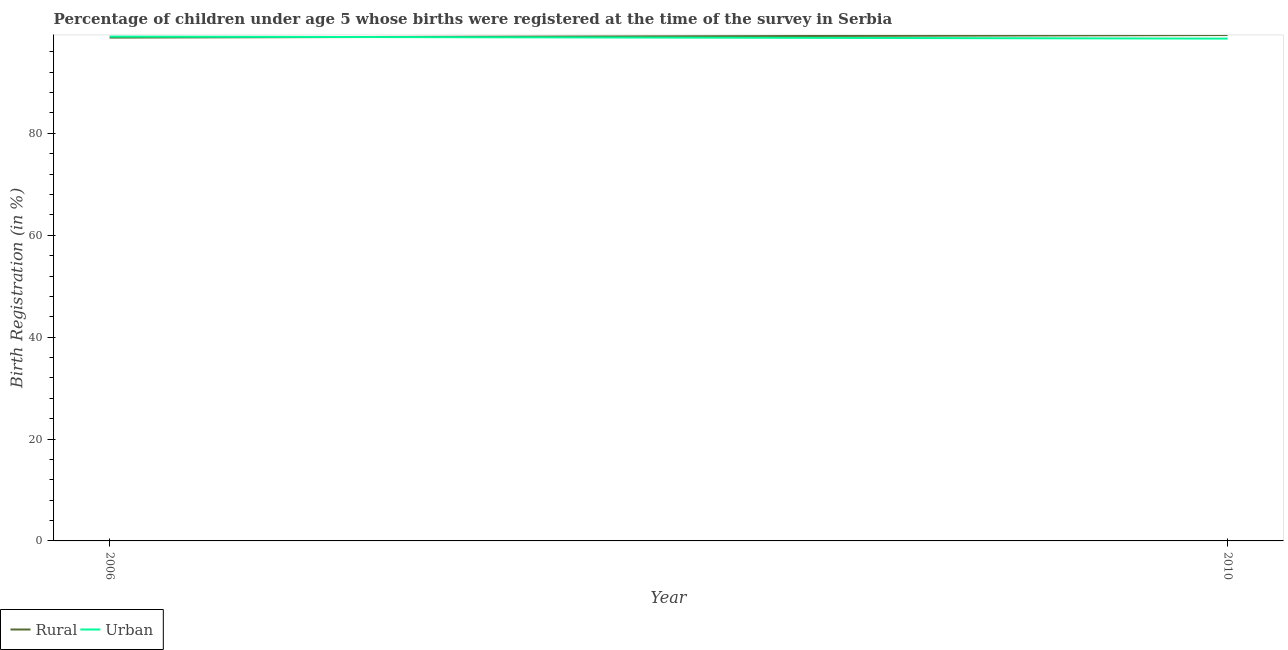How many different coloured lines are there?
Ensure brevity in your answer.  2. Is the number of lines equal to the number of legend labels?
Keep it short and to the point. Yes. What is the rural birth registration in 2006?
Make the answer very short. 98.8. Across all years, what is the maximum rural birth registration?
Make the answer very short. 99.3. Across all years, what is the minimum rural birth registration?
Provide a succinct answer. 98.8. In which year was the urban birth registration maximum?
Your answer should be very brief. 2006. In which year was the rural birth registration minimum?
Your answer should be very brief. 2006. What is the total urban birth registration in the graph?
Offer a very short reply. 197.6. What is the difference between the rural birth registration in 2006 and that in 2010?
Your response must be concise. -0.5. What is the difference between the rural birth registration in 2010 and the urban birth registration in 2006?
Make the answer very short. 0.3. What is the average urban birth registration per year?
Make the answer very short. 98.8. In the year 2006, what is the difference between the urban birth registration and rural birth registration?
Your answer should be very brief. 0.2. In how many years, is the urban birth registration greater than 56 %?
Give a very brief answer. 2. What is the ratio of the urban birth registration in 2006 to that in 2010?
Offer a very short reply. 1. In how many years, is the rural birth registration greater than the average rural birth registration taken over all years?
Provide a short and direct response. 1. Is the rural birth registration strictly less than the urban birth registration over the years?
Keep it short and to the point. No. How many lines are there?
Provide a succinct answer. 2. Are the values on the major ticks of Y-axis written in scientific E-notation?
Your answer should be compact. No. Does the graph contain any zero values?
Offer a very short reply. No. How many legend labels are there?
Your answer should be very brief. 2. What is the title of the graph?
Make the answer very short. Percentage of children under age 5 whose births were registered at the time of the survey in Serbia. Does "Number of arrivals" appear as one of the legend labels in the graph?
Provide a short and direct response. No. What is the label or title of the X-axis?
Your answer should be very brief. Year. What is the label or title of the Y-axis?
Offer a terse response. Birth Registration (in %). What is the Birth Registration (in %) in Rural in 2006?
Offer a terse response. 98.8. What is the Birth Registration (in %) in Rural in 2010?
Your answer should be compact. 99.3. What is the Birth Registration (in %) in Urban in 2010?
Your answer should be compact. 98.6. Across all years, what is the maximum Birth Registration (in %) of Rural?
Provide a succinct answer. 99.3. Across all years, what is the minimum Birth Registration (in %) of Rural?
Keep it short and to the point. 98.8. Across all years, what is the minimum Birth Registration (in %) in Urban?
Ensure brevity in your answer.  98.6. What is the total Birth Registration (in %) in Rural in the graph?
Provide a short and direct response. 198.1. What is the total Birth Registration (in %) of Urban in the graph?
Offer a very short reply. 197.6. What is the difference between the Birth Registration (in %) in Rural in 2006 and that in 2010?
Your answer should be very brief. -0.5. What is the difference between the Birth Registration (in %) of Urban in 2006 and that in 2010?
Your answer should be compact. 0.4. What is the average Birth Registration (in %) of Rural per year?
Your response must be concise. 99.05. What is the average Birth Registration (in %) in Urban per year?
Ensure brevity in your answer.  98.8. What is the ratio of the Birth Registration (in %) of Rural in 2006 to that in 2010?
Give a very brief answer. 0.99. What is the difference between the highest and the second highest Birth Registration (in %) of Rural?
Make the answer very short. 0.5. What is the difference between the highest and the lowest Birth Registration (in %) in Rural?
Make the answer very short. 0.5. 